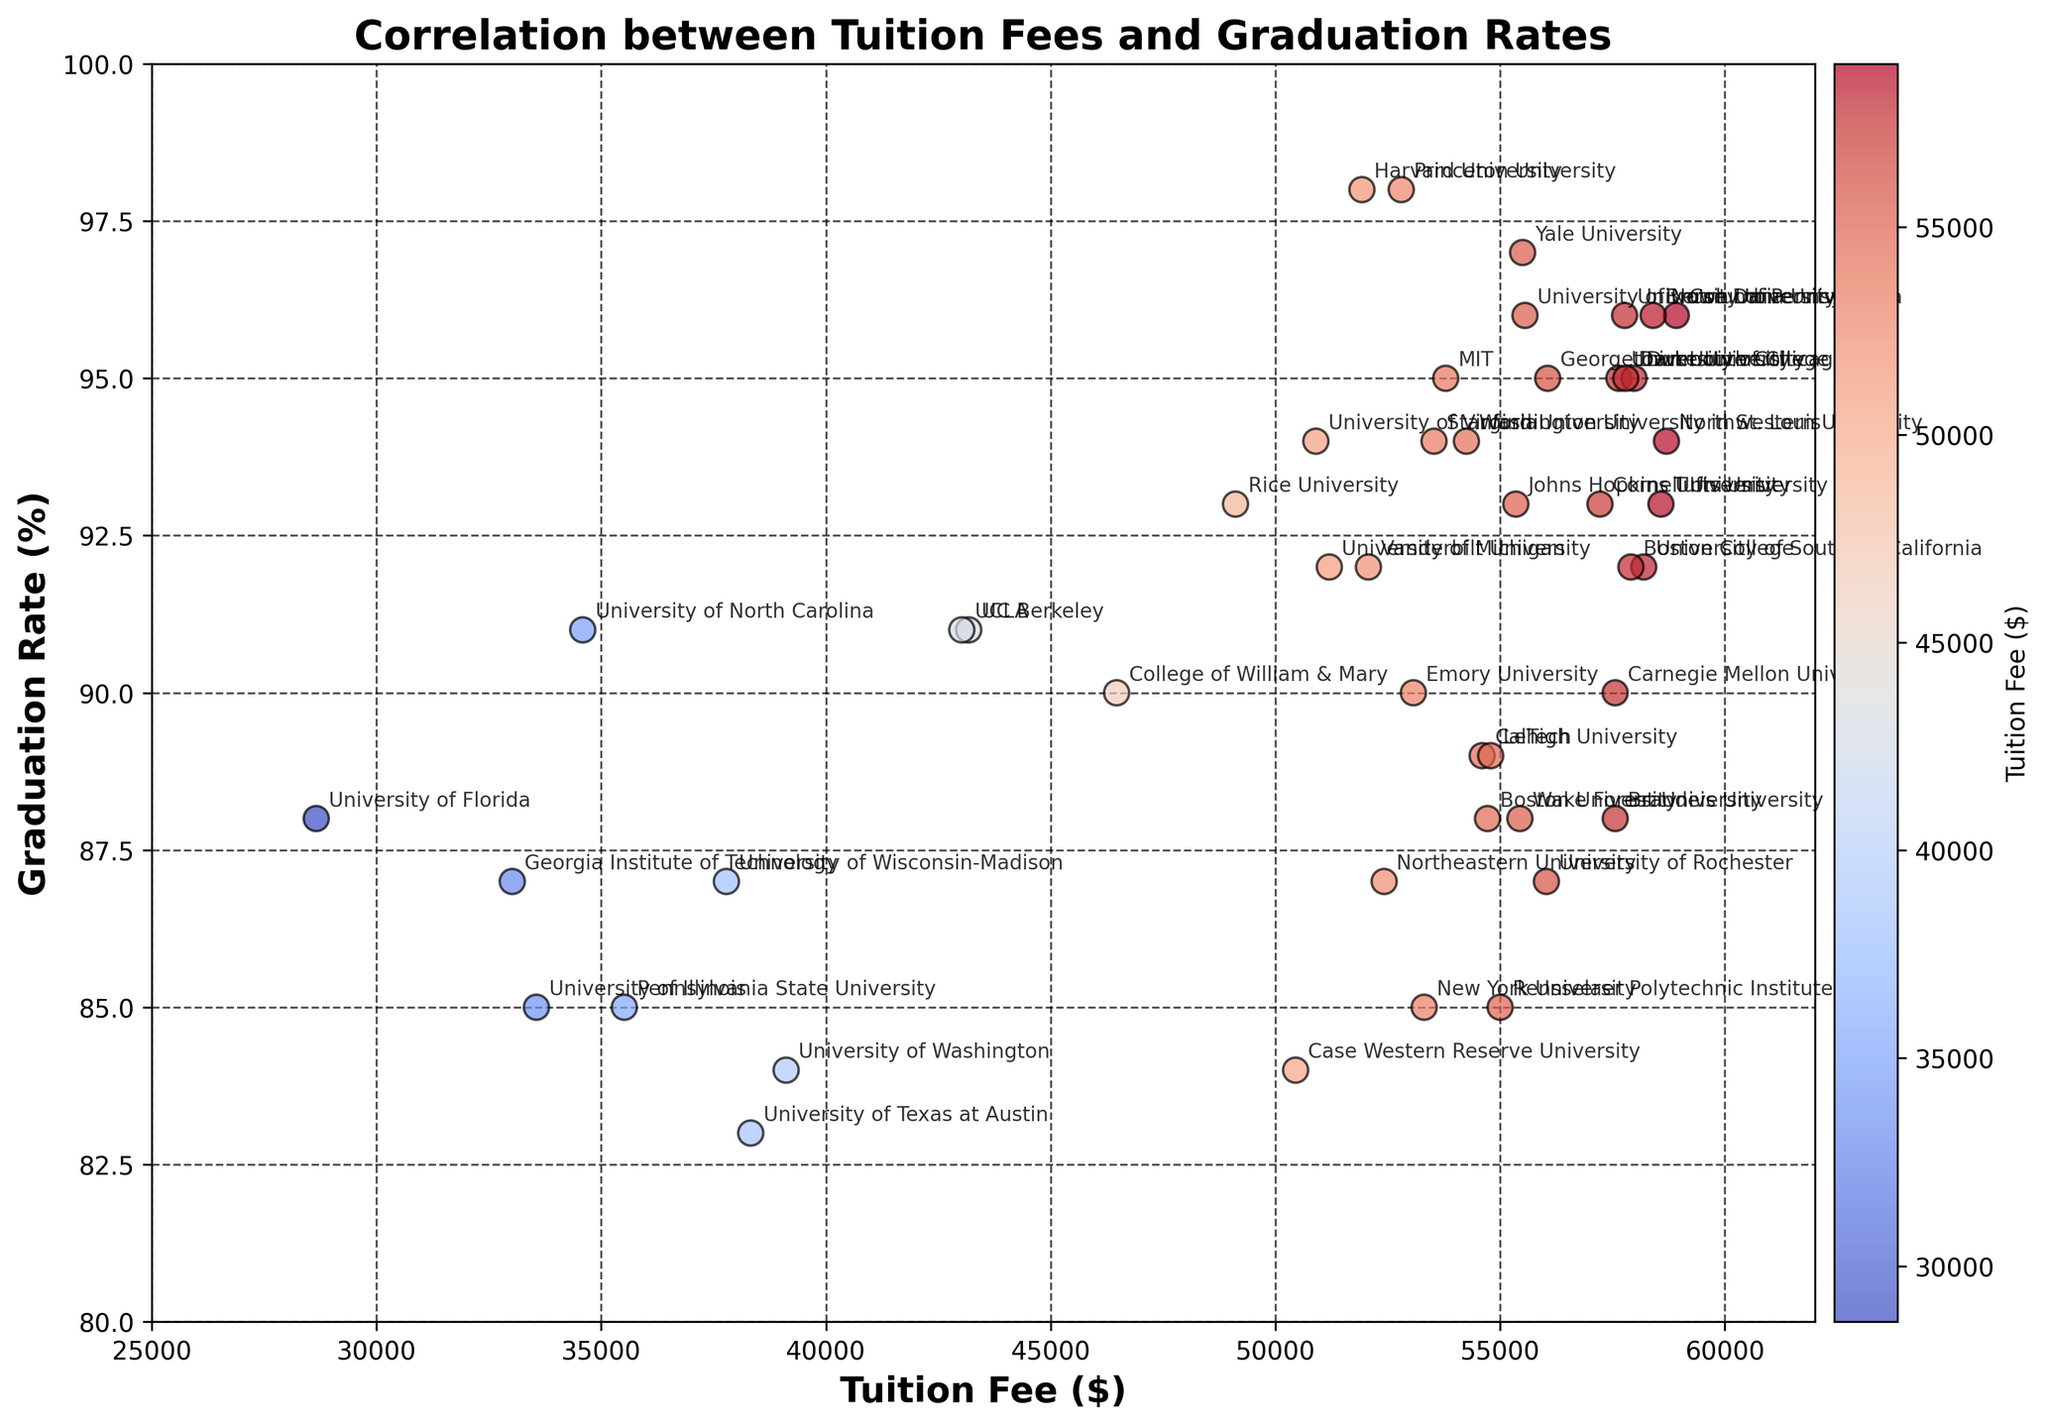Which university has the highest tuition fee? The scatter plot shows tuition fees on the x-axis. The university with the highest value on this axis will be the answer. The highest tuition fee is noted just beyond the $58,000 mark. This is Columbia University with about $58,920.
Answer: Columbia University What is the graduation rate for the university with the lowest tuition fee? The scatter plot shows the lowest tuition fee around $28,659. The university associated with this tuition fee is the University of Florida, and its position on the y-axis shows a graduation rate of approximately 88%.
Answer: 88% Which university has a higher graduation rate: Yale University or Stanford University? Yale University and Stanford University can be located on the plot by their x positions for tuition fees ($55,500 and $53,529 respectively). The y-axis positions show their graduation rates. Yale University has a graduation rate of 97% and Stanford University has a rate of 94%.
Answer: Yale University How does the graduation rate of the University of Texas at Austin compare to that of New York University? Locate University of Texas at Austin and New York University on the scatter plot using their tuition fees ($38,326 and $53,310 respectively). The y-axis positions indicate their graduation rates. University of Texas at Austin has a graduation rate of 83%, and New York University has a graduation rate of 85%.
Answer: New York University has a higher rate Which university has a similar tuition fee but a lower graduation rate compared to Princeton University? Princeton University has a tuition fee around $52,800 with a graduation rate of 98%. Scan for other points around $52,800 on the x-axis and identify those with y values < 98%. Northeastern University has a tuition fee of about $52,420 with a graduation rate of 87%.
Answer: Northeastern University Is there any university with over 90% graduation rate that has a tuition fee under $40,000? Look for points above the 90% mark on the y-axis and check their corresponding x values. At around $35,588, University of North Carolina fits this criterion with a graduation rate of 91%.
Answer: University of North Carolina What is the difference in graduation rates between the universities with the highest and lowest tuition fees? The highest tuition fee is $58,920 (Columbia University) and the lowest is $28,659 (University of Florida). Their graduation rates are 96% and 88% respectively. Calculate the difference: 96% - 88% = 8%.
Answer: 8% Which university with a tuition fee close to $57,000 has the highest graduation rate? Examine the scatter plot around the $57,000 mark on the x-axis and check for the highest point on the y-axis near this x value. University of Chicago and Georgetown University meet this criterion with graduation rates of 95% each. Among them, University of Chicago is slightly more expensive with $57642 of tuition fee.
Answer: University of Chicago 